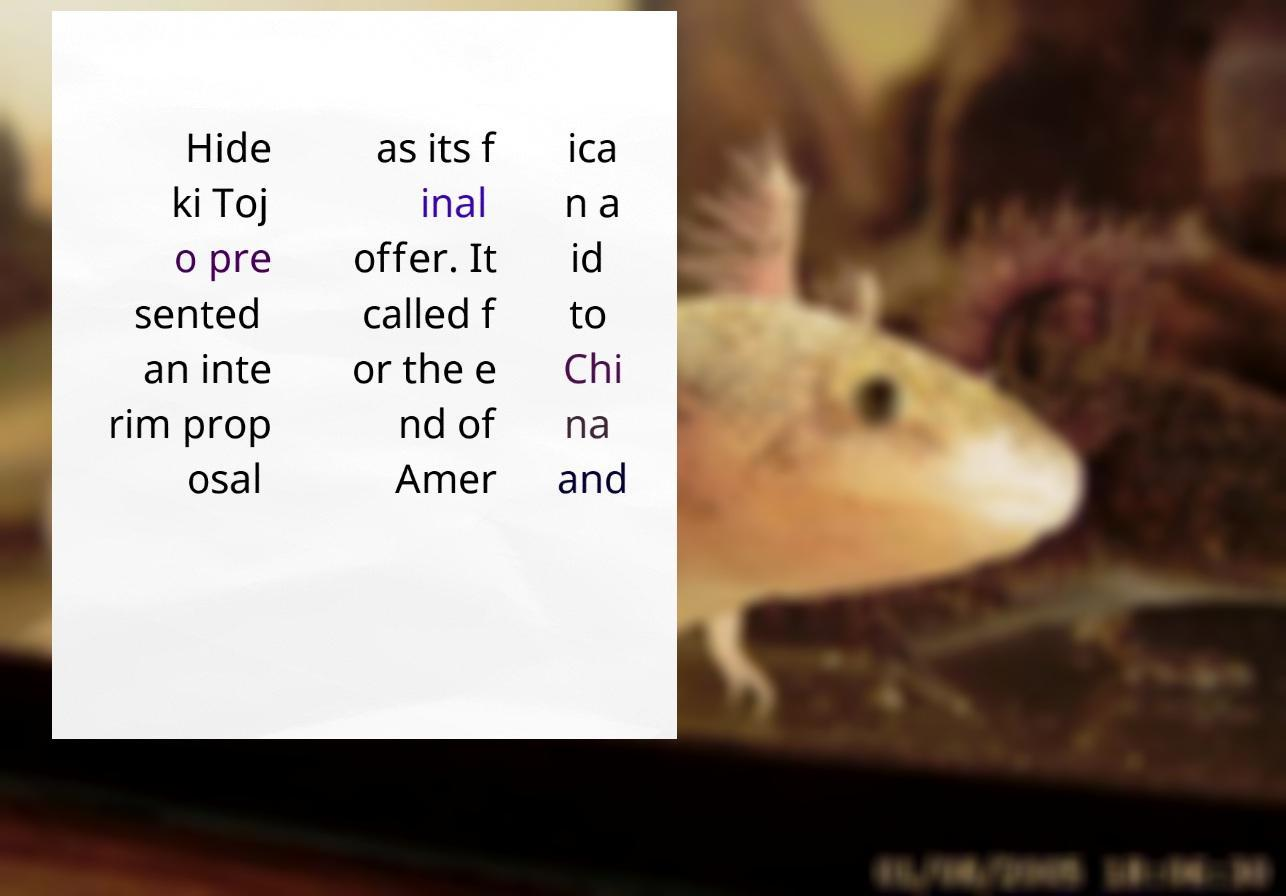Please read and relay the text visible in this image. What does it say? Hide ki Toj o pre sented an inte rim prop osal as its f inal offer. It called f or the e nd of Amer ica n a id to Chi na and 